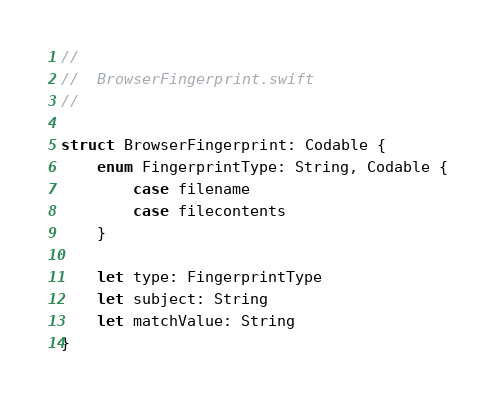<code> <loc_0><loc_0><loc_500><loc_500><_Swift_>//
//  BrowserFingerprint.swift
//

struct BrowserFingerprint: Codable {
    enum FingerprintType: String, Codable {
        case filename
        case filecontents
    }
    
    let type: FingerprintType
    let subject: String
    let matchValue: String
}
</code> 